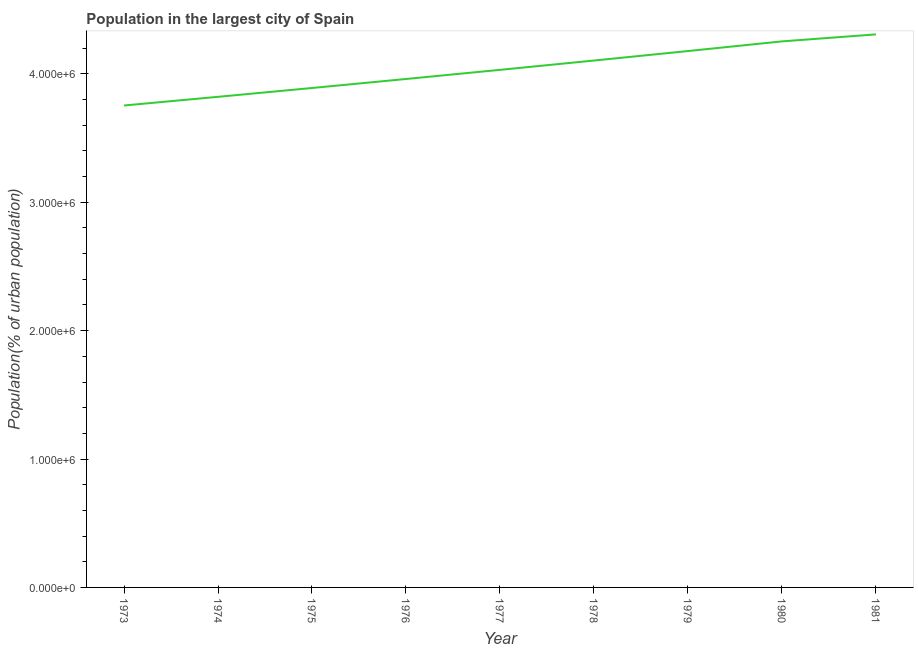What is the population in largest city in 1980?
Offer a terse response. 4.25e+06. Across all years, what is the maximum population in largest city?
Your answer should be very brief. 4.31e+06. Across all years, what is the minimum population in largest city?
Provide a short and direct response. 3.75e+06. In which year was the population in largest city maximum?
Ensure brevity in your answer.  1981. In which year was the population in largest city minimum?
Ensure brevity in your answer.  1973. What is the sum of the population in largest city?
Give a very brief answer. 3.63e+07. What is the difference between the population in largest city in 1974 and 1981?
Keep it short and to the point. -4.86e+05. What is the average population in largest city per year?
Your answer should be compact. 4.03e+06. What is the median population in largest city?
Your answer should be compact. 4.03e+06. In how many years, is the population in largest city greater than 3800000 %?
Your response must be concise. 8. What is the ratio of the population in largest city in 1980 to that in 1981?
Provide a succinct answer. 0.99. Is the population in largest city in 1973 less than that in 1981?
Provide a succinct answer. Yes. What is the difference between the highest and the second highest population in largest city?
Provide a succinct answer. 5.46e+04. Is the sum of the population in largest city in 1973 and 1978 greater than the maximum population in largest city across all years?
Give a very brief answer. Yes. What is the difference between the highest and the lowest population in largest city?
Give a very brief answer. 5.54e+05. In how many years, is the population in largest city greater than the average population in largest city taken over all years?
Your answer should be compact. 4. Does the population in largest city monotonically increase over the years?
Make the answer very short. Yes. How many lines are there?
Provide a succinct answer. 1. Are the values on the major ticks of Y-axis written in scientific E-notation?
Your answer should be very brief. Yes. What is the title of the graph?
Provide a succinct answer. Population in the largest city of Spain. What is the label or title of the X-axis?
Offer a terse response. Year. What is the label or title of the Y-axis?
Your response must be concise. Population(% of urban population). What is the Population(% of urban population) of 1973?
Provide a succinct answer. 3.75e+06. What is the Population(% of urban population) of 1974?
Make the answer very short. 3.82e+06. What is the Population(% of urban population) of 1975?
Your response must be concise. 3.89e+06. What is the Population(% of urban population) in 1976?
Offer a very short reply. 3.96e+06. What is the Population(% of urban population) in 1977?
Make the answer very short. 4.03e+06. What is the Population(% of urban population) of 1978?
Provide a short and direct response. 4.10e+06. What is the Population(% of urban population) of 1979?
Your response must be concise. 4.18e+06. What is the Population(% of urban population) in 1980?
Make the answer very short. 4.25e+06. What is the Population(% of urban population) of 1981?
Your answer should be compact. 4.31e+06. What is the difference between the Population(% of urban population) in 1973 and 1974?
Your response must be concise. -6.76e+04. What is the difference between the Population(% of urban population) in 1973 and 1975?
Offer a very short reply. -1.36e+05. What is the difference between the Population(% of urban population) in 1973 and 1976?
Make the answer very short. -2.06e+05. What is the difference between the Population(% of urban population) in 1973 and 1977?
Make the answer very short. -2.78e+05. What is the difference between the Population(% of urban population) in 1973 and 1978?
Your answer should be compact. -3.50e+05. What is the difference between the Population(% of urban population) in 1973 and 1979?
Your response must be concise. -4.24e+05. What is the difference between the Population(% of urban population) in 1973 and 1980?
Your response must be concise. -4.99e+05. What is the difference between the Population(% of urban population) in 1973 and 1981?
Provide a short and direct response. -5.54e+05. What is the difference between the Population(% of urban population) in 1974 and 1975?
Offer a terse response. -6.88e+04. What is the difference between the Population(% of urban population) in 1974 and 1976?
Your answer should be compact. -1.39e+05. What is the difference between the Population(% of urban population) in 1974 and 1977?
Offer a very short reply. -2.10e+05. What is the difference between the Population(% of urban population) in 1974 and 1978?
Your answer should be compact. -2.83e+05. What is the difference between the Population(% of urban population) in 1974 and 1979?
Keep it short and to the point. -3.56e+05. What is the difference between the Population(% of urban population) in 1974 and 1980?
Give a very brief answer. -4.32e+05. What is the difference between the Population(% of urban population) in 1974 and 1981?
Your answer should be very brief. -4.86e+05. What is the difference between the Population(% of urban population) in 1975 and 1976?
Provide a short and direct response. -7.01e+04. What is the difference between the Population(% of urban population) in 1975 and 1977?
Your answer should be very brief. -1.41e+05. What is the difference between the Population(% of urban population) in 1975 and 1978?
Ensure brevity in your answer.  -2.14e+05. What is the difference between the Population(% of urban population) in 1975 and 1979?
Make the answer very short. -2.88e+05. What is the difference between the Population(% of urban population) in 1975 and 1980?
Provide a succinct answer. -3.63e+05. What is the difference between the Population(% of urban population) in 1975 and 1981?
Your answer should be compact. -4.18e+05. What is the difference between the Population(% of urban population) in 1976 and 1977?
Ensure brevity in your answer.  -7.12e+04. What is the difference between the Population(% of urban population) in 1976 and 1978?
Keep it short and to the point. -1.44e+05. What is the difference between the Population(% of urban population) in 1976 and 1979?
Offer a terse response. -2.18e+05. What is the difference between the Population(% of urban population) in 1976 and 1980?
Provide a short and direct response. -2.93e+05. What is the difference between the Population(% of urban population) in 1976 and 1981?
Offer a terse response. -3.47e+05. What is the difference between the Population(% of urban population) in 1977 and 1978?
Ensure brevity in your answer.  -7.26e+04. What is the difference between the Population(% of urban population) in 1977 and 1979?
Provide a short and direct response. -1.46e+05. What is the difference between the Population(% of urban population) in 1977 and 1980?
Your answer should be very brief. -2.22e+05. What is the difference between the Population(% of urban population) in 1977 and 1981?
Give a very brief answer. -2.76e+05. What is the difference between the Population(% of urban population) in 1978 and 1979?
Offer a very short reply. -7.39e+04. What is the difference between the Population(% of urban population) in 1978 and 1980?
Make the answer very short. -1.49e+05. What is the difference between the Population(% of urban population) in 1978 and 1981?
Give a very brief answer. -2.04e+05. What is the difference between the Population(% of urban population) in 1979 and 1980?
Give a very brief answer. -7.53e+04. What is the difference between the Population(% of urban population) in 1979 and 1981?
Offer a very short reply. -1.30e+05. What is the difference between the Population(% of urban population) in 1980 and 1981?
Offer a terse response. -5.46e+04. What is the ratio of the Population(% of urban population) in 1973 to that in 1974?
Provide a succinct answer. 0.98. What is the ratio of the Population(% of urban population) in 1973 to that in 1976?
Provide a succinct answer. 0.95. What is the ratio of the Population(% of urban population) in 1973 to that in 1977?
Make the answer very short. 0.93. What is the ratio of the Population(% of urban population) in 1973 to that in 1978?
Offer a terse response. 0.92. What is the ratio of the Population(% of urban population) in 1973 to that in 1979?
Provide a short and direct response. 0.9. What is the ratio of the Population(% of urban population) in 1973 to that in 1980?
Provide a short and direct response. 0.88. What is the ratio of the Population(% of urban population) in 1973 to that in 1981?
Provide a succinct answer. 0.87. What is the ratio of the Population(% of urban population) in 1974 to that in 1977?
Provide a short and direct response. 0.95. What is the ratio of the Population(% of urban population) in 1974 to that in 1979?
Make the answer very short. 0.92. What is the ratio of the Population(% of urban population) in 1974 to that in 1980?
Your response must be concise. 0.9. What is the ratio of the Population(% of urban population) in 1974 to that in 1981?
Make the answer very short. 0.89. What is the ratio of the Population(% of urban population) in 1975 to that in 1978?
Offer a terse response. 0.95. What is the ratio of the Population(% of urban population) in 1975 to that in 1980?
Offer a terse response. 0.92. What is the ratio of the Population(% of urban population) in 1975 to that in 1981?
Your answer should be very brief. 0.9. What is the ratio of the Population(% of urban population) in 1976 to that in 1978?
Your answer should be compact. 0.96. What is the ratio of the Population(% of urban population) in 1976 to that in 1979?
Offer a terse response. 0.95. What is the ratio of the Population(% of urban population) in 1976 to that in 1981?
Make the answer very short. 0.92. What is the ratio of the Population(% of urban population) in 1977 to that in 1978?
Your response must be concise. 0.98. What is the ratio of the Population(% of urban population) in 1977 to that in 1980?
Provide a succinct answer. 0.95. What is the ratio of the Population(% of urban population) in 1977 to that in 1981?
Your answer should be very brief. 0.94. What is the ratio of the Population(% of urban population) in 1978 to that in 1979?
Ensure brevity in your answer.  0.98. What is the ratio of the Population(% of urban population) in 1978 to that in 1981?
Provide a succinct answer. 0.95. What is the ratio of the Population(% of urban population) in 1980 to that in 1981?
Your answer should be very brief. 0.99. 